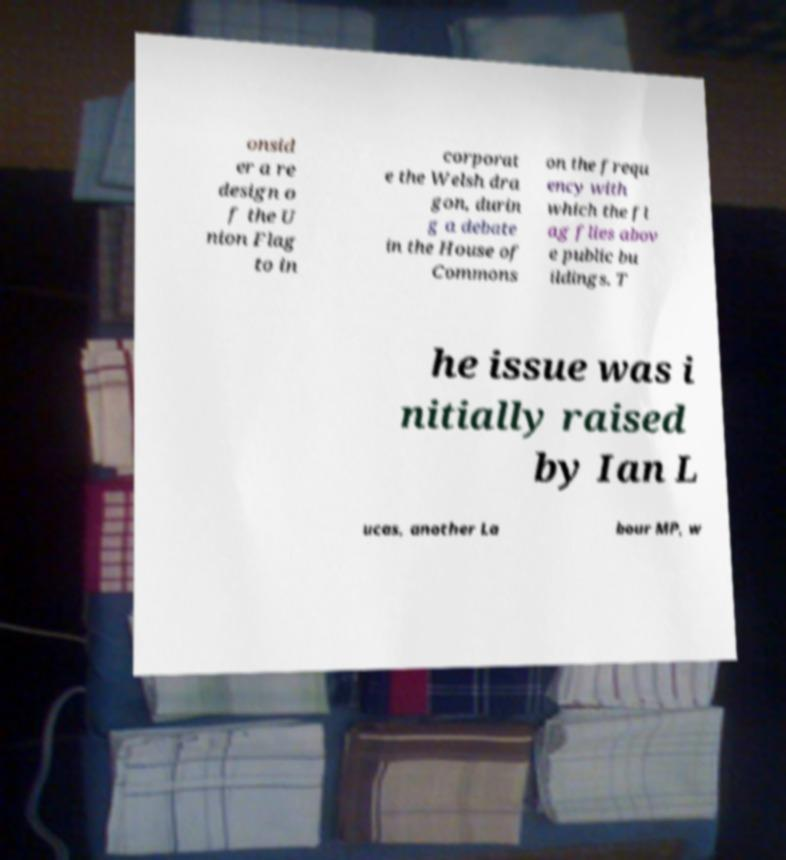I need the written content from this picture converted into text. Can you do that? onsid er a re design o f the U nion Flag to in corporat e the Welsh dra gon, durin g a debate in the House of Commons on the frequ ency with which the fl ag flies abov e public bu ildings. T he issue was i nitially raised by Ian L ucas, another La bour MP, w 